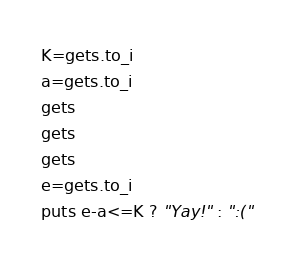Convert code to text. <code><loc_0><loc_0><loc_500><loc_500><_Ruby_>K=gets.to_i
a=gets.to_i
gets
gets
gets
e=gets.to_i
puts e-a<=K ? "Yay!" : ":("

</code> 